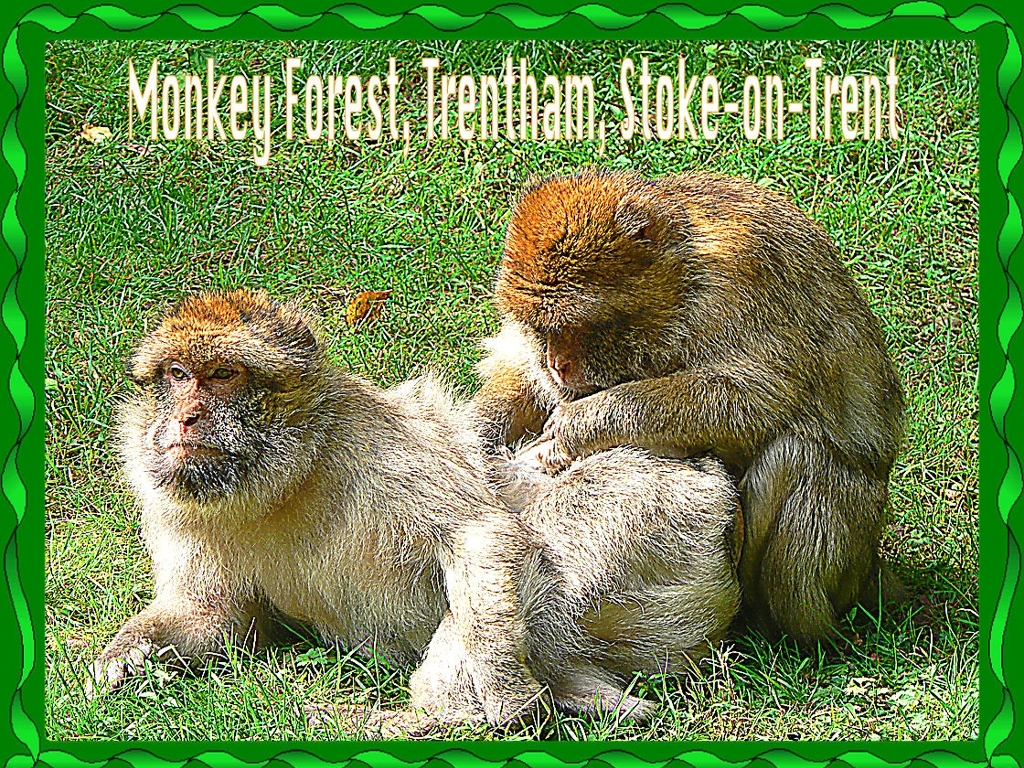Is there any noise in this image? Upon inspection, there doesn't appear to be any visual 'noise' or distortion in the image; the photograph is clear with well-defined subjects and a distinct foreground. The tranquility of the scene, with two monkeys grooming in a natural setting, suggests a serene environment typically devoid of disruptive sounds, although an image alone cannot convey actual auditory noise. 